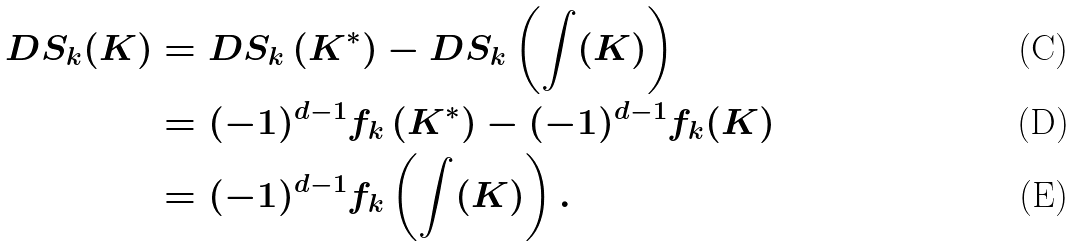Convert formula to latex. <formula><loc_0><loc_0><loc_500><loc_500>D S _ { k } ( K ) & = D S _ { k } \left ( K ^ { * } \right ) - D S _ { k } \left ( \int ( K ) \right ) \\ & = ( - 1 ) ^ { d - 1 } f _ { k } \left ( K ^ { * } \right ) - ( - 1 ) ^ { d - 1 } f _ { k } ( K ) \\ & = ( - 1 ) ^ { d - 1 } f _ { k } \left ( \int ( K ) \right ) .</formula> 